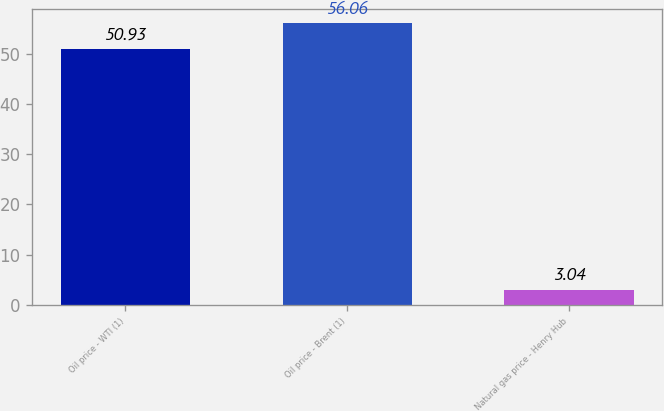<chart> <loc_0><loc_0><loc_500><loc_500><bar_chart><fcel>Oil price - WTI (1)<fcel>Oil price - Brent (1)<fcel>Natural gas price - Henry Hub<nl><fcel>50.93<fcel>56.06<fcel>3.04<nl></chart> 